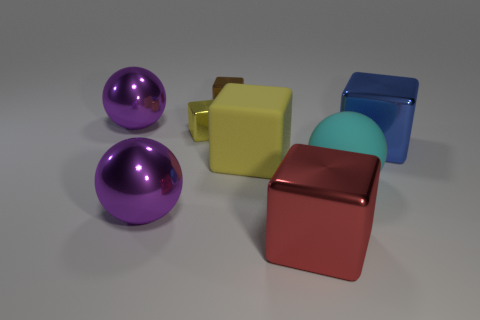Subtract 2 blocks. How many blocks are left? 3 Subtract all red balls. Subtract all blue cylinders. How many balls are left? 3 Add 1 small brown metal cubes. How many objects exist? 9 Subtract all spheres. How many objects are left? 5 Subtract all large purple things. Subtract all large purple things. How many objects are left? 4 Add 7 matte blocks. How many matte blocks are left? 8 Add 4 big purple objects. How many big purple objects exist? 6 Subtract 0 yellow balls. How many objects are left? 8 